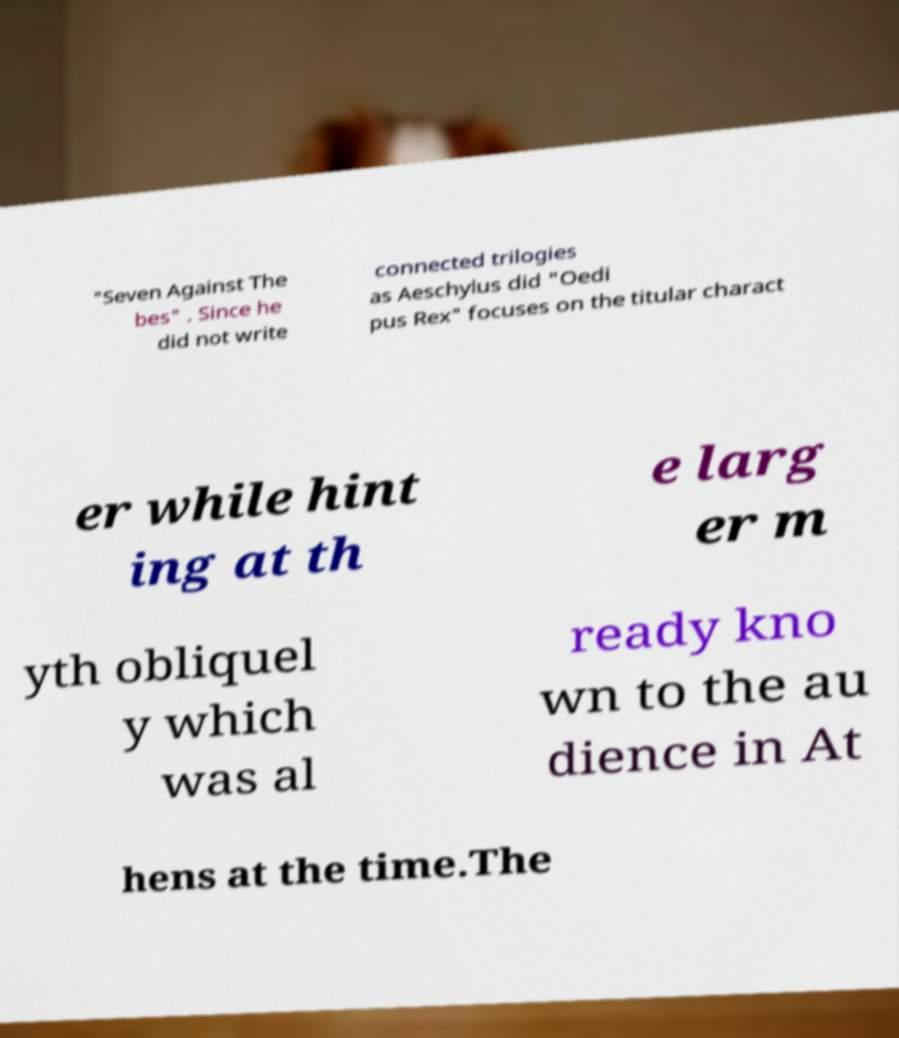I need the written content from this picture converted into text. Can you do that? "Seven Against The bes" . Since he did not write connected trilogies as Aeschylus did "Oedi pus Rex" focuses on the titular charact er while hint ing at th e larg er m yth obliquel y which was al ready kno wn to the au dience in At hens at the time.The 